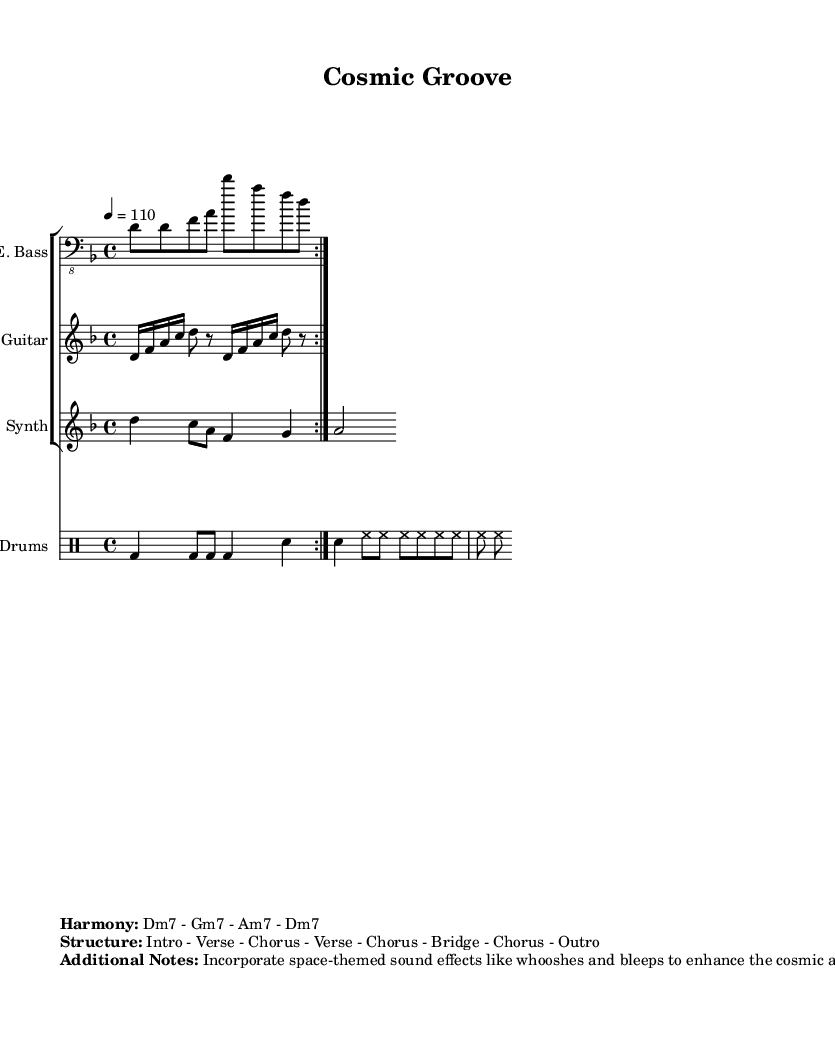What is the key signature of this music? The key signature is represented at the beginning of the staff, which shows two flat symbols, indicating the use of B flat and E flat. This key signature corresponds to D minor.
Answer: D minor What is the time signature of this piece? The time signature appears at the beginning, shown as 4/4, meaning there are four beats in each measure and the quarter note gets one beat.
Answer: 4/4 What is the tempo marking for this composition? The tempo marking is indicated by the number "4 = 110," which signifies that the quarter note should be played at a speed of 110 beats per minute.
Answer: 110 How many measures are in the chorus section? From the structure provided, the chorus is mentioned to be repeated three times in the overall composition. Each repeat typically represents a measure grouping, but it's primarily indicated by the term chorus, which corresponds to measures, typically four in most styles.
Answer: 4 What type of chord progression is used in the harmony? The chord progression listed under "Harmony" is shown as "Dm7 - Gm7 - Am7 - Dm7," indicating the specific seventh chords moving in a minor context.
Answer: Dm7 - Gm7 - Am7 - Dm7 What unique elements are suggested for enhancing the cosmic atmosphere? The additional notes section indicates to incorporate space-themed sound effects like "whooshes and bleeps," which would create a celestial ambiance when added to the funk instrumental.
Answer: Whooshes and bleeps What structure is outlined for this composition? The structure is detailed through a series of labels such as "Intro - Verse - Chorus - Verse - Chorus - Bridge - Chorus - Outro," showing the order of sections in the composition.
Answer: Intro - Verse - Chorus - Verse - Chorus - Bridge - Chorus - Outro 